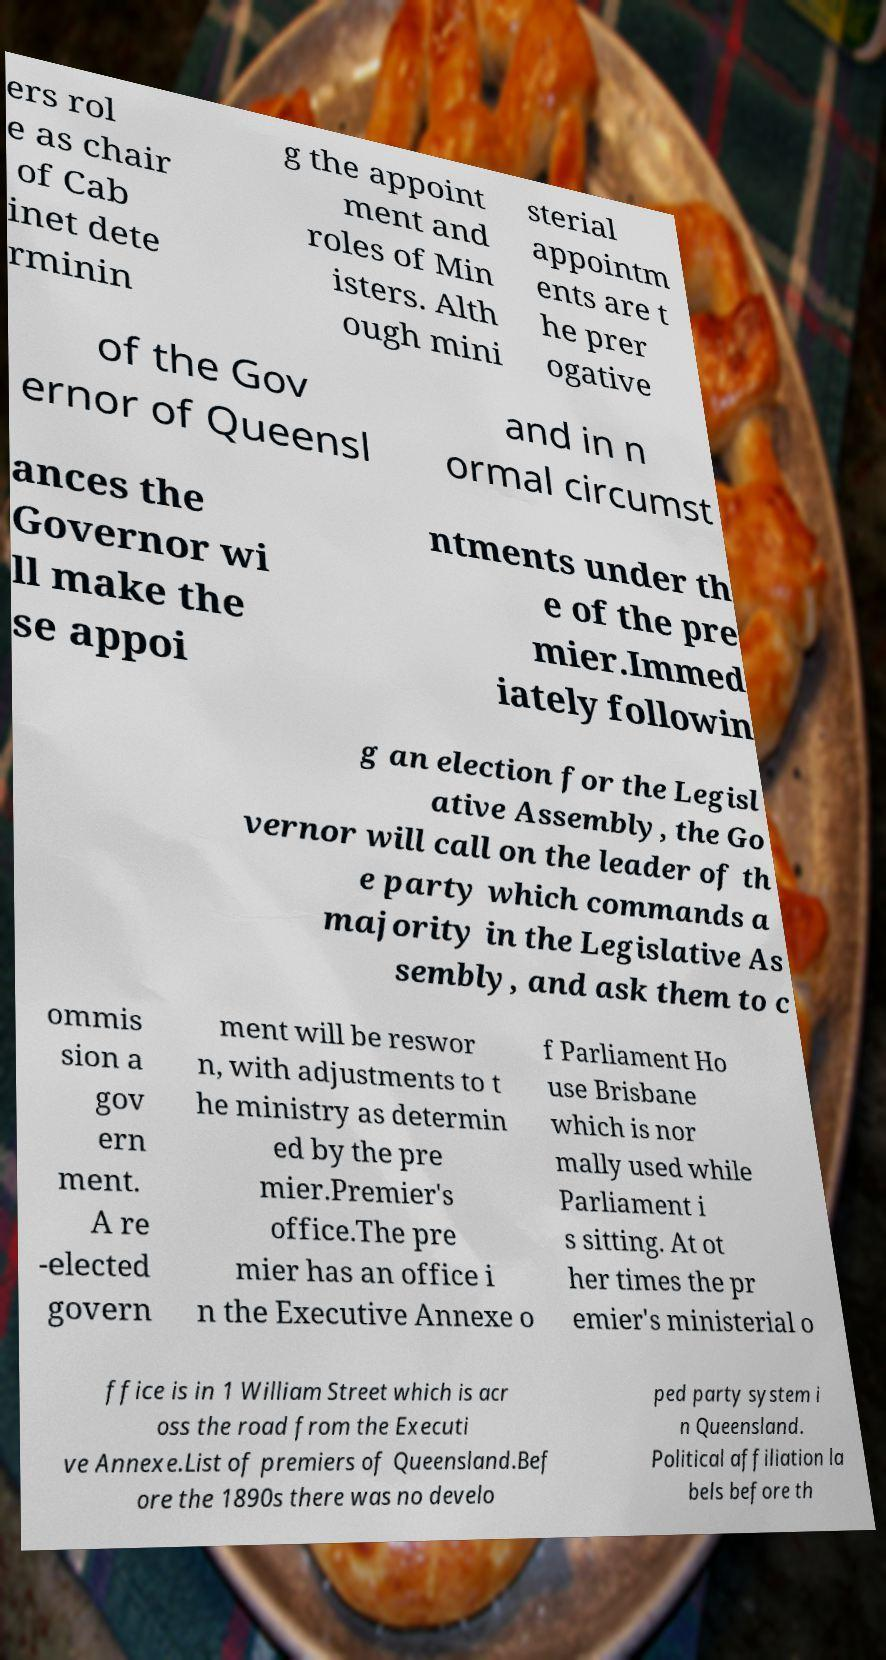There's text embedded in this image that I need extracted. Can you transcribe it verbatim? ers rol e as chair of Cab inet dete rminin g the appoint ment and roles of Min isters. Alth ough mini sterial appointm ents are t he prer ogative of the Gov ernor of Queensl and in n ormal circumst ances the Governor wi ll make the se appoi ntments under th e of the pre mier.Immed iately followin g an election for the Legisl ative Assembly, the Go vernor will call on the leader of th e party which commands a majority in the Legislative As sembly, and ask them to c ommis sion a gov ern ment. A re -elected govern ment will be reswor n, with adjustments to t he ministry as determin ed by the pre mier.Premier's office.The pre mier has an office i n the Executive Annexe o f Parliament Ho use Brisbane which is nor mally used while Parliament i s sitting. At ot her times the pr emier's ministerial o ffice is in 1 William Street which is acr oss the road from the Executi ve Annexe.List of premiers of Queensland.Bef ore the 1890s there was no develo ped party system i n Queensland. Political affiliation la bels before th 